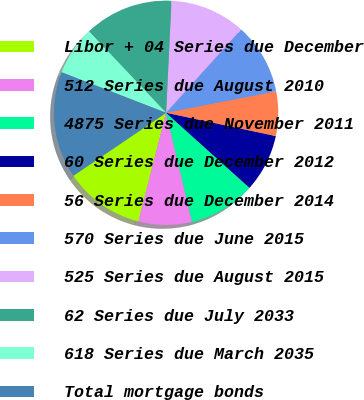<chart> <loc_0><loc_0><loc_500><loc_500><pie_chart><fcel>Libor + 04 Series due December<fcel>512 Series due August 2010<fcel>4875 Series due November 2011<fcel>60 Series due December 2012<fcel>56 Series due December 2014<fcel>570 Series due June 2015<fcel>525 Series due August 2015<fcel>62 Series due July 2033<fcel>618 Series due March 2035<fcel>Total mortgage bonds<nl><fcel>11.54%<fcel>7.69%<fcel>9.62%<fcel>8.33%<fcel>6.41%<fcel>10.26%<fcel>10.9%<fcel>12.82%<fcel>7.05%<fcel>15.38%<nl></chart> 